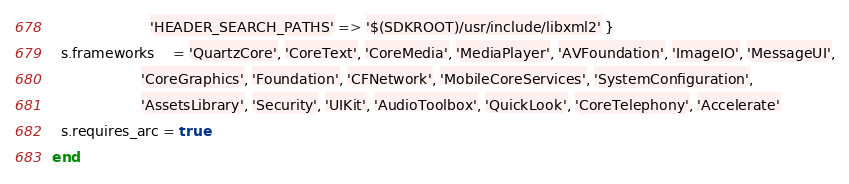<code> <loc_0><loc_0><loc_500><loc_500><_Ruby_>                      'HEADER_SEARCH_PATHS' => '$(SDKROOT)/usr/include/libxml2' }
  s.frameworks    = 'QuartzCore', 'CoreText', 'CoreMedia', 'MediaPlayer', 'AVFoundation', 'ImageIO', 'MessageUI',
                    'CoreGraphics', 'Foundation', 'CFNetwork', 'MobileCoreServices', 'SystemConfiguration',
                    'AssetsLibrary', 'Security', 'UIKit', 'AudioToolbox', 'QuickLook', 'CoreTelephony', 'Accelerate'
  s.requires_arc = true
end
</code> 